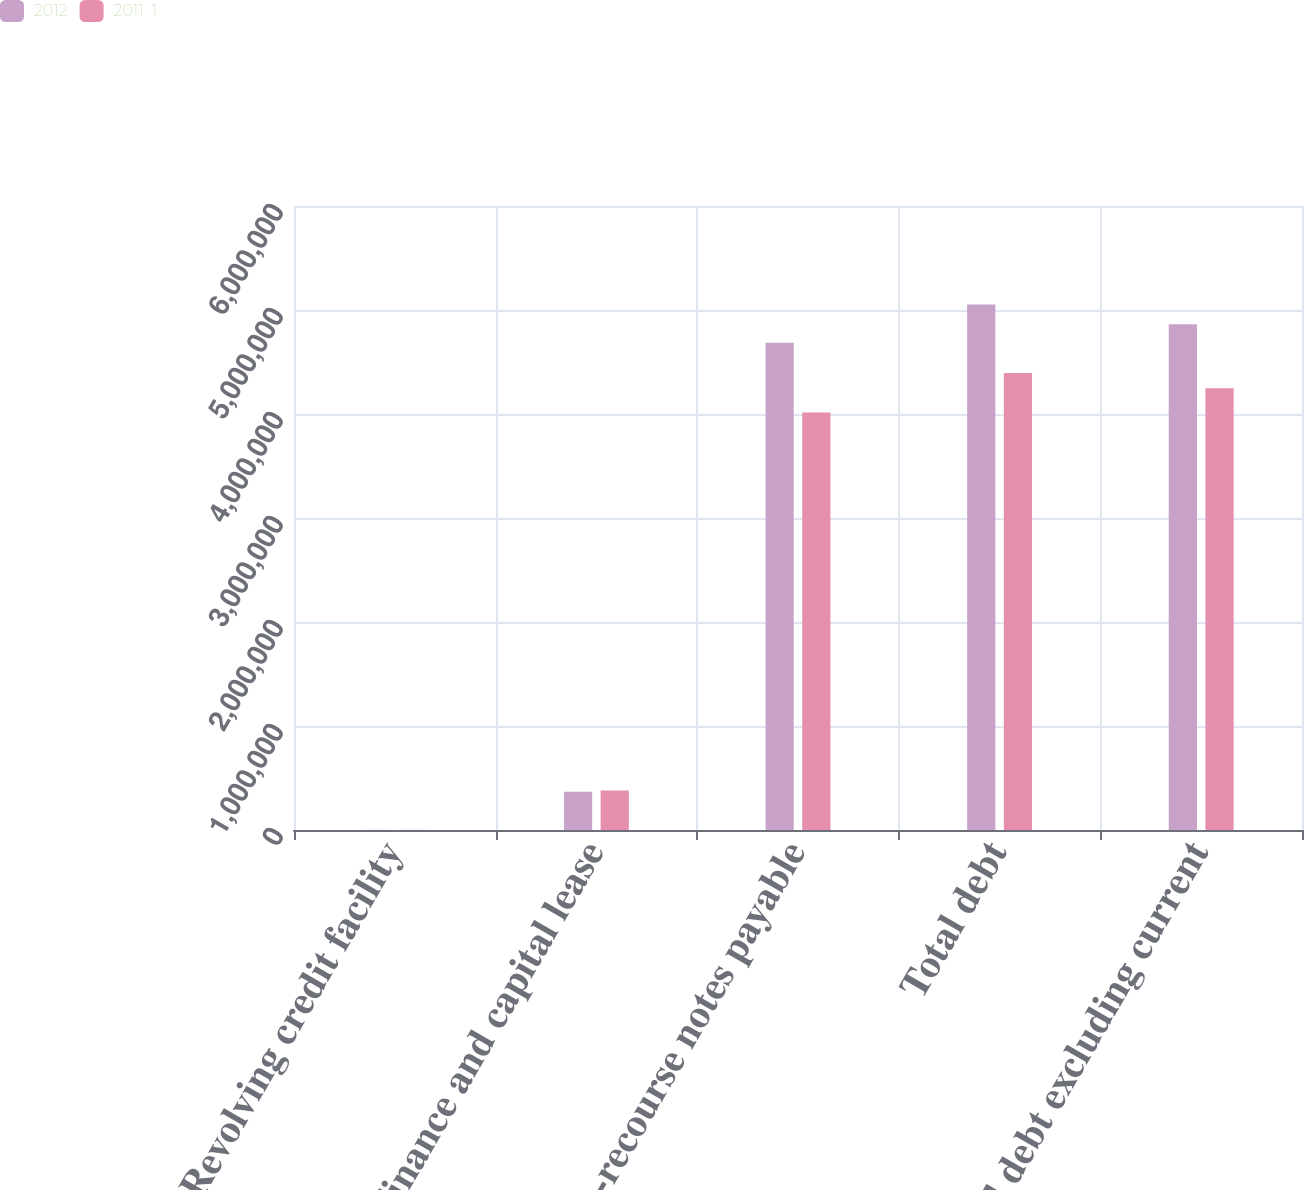Convert chart. <chart><loc_0><loc_0><loc_500><loc_500><stacked_bar_chart><ecel><fcel>Revolving credit facility<fcel>Finance and capital lease<fcel>Non-recourse notes payable<fcel>Total debt<fcel>Total debt excluding current<nl><fcel>2012<fcel>943<fcel>367674<fcel>4.68409e+06<fcel>5.05271e+06<fcel>4.86332e+06<nl><fcel>2011  1<fcel>1002<fcel>380234<fcel>4.01366e+06<fcel>4.3949e+06<fcel>4.24876e+06<nl></chart> 